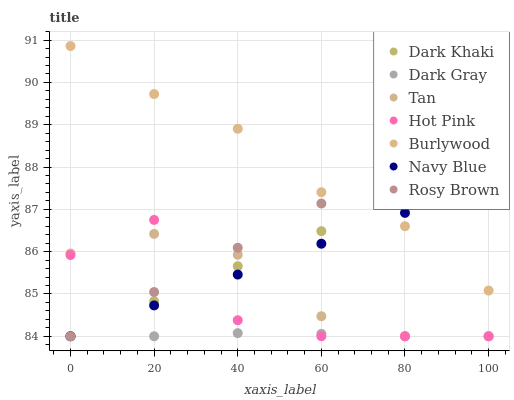Does Dark Gray have the minimum area under the curve?
Answer yes or no. Yes. Does Burlywood have the maximum area under the curve?
Answer yes or no. Yes. Does Rosy Brown have the minimum area under the curve?
Answer yes or no. No. Does Rosy Brown have the maximum area under the curve?
Answer yes or no. No. Is Dark Khaki the smoothest?
Answer yes or no. Yes. Is Hot Pink the roughest?
Answer yes or no. Yes. Is Rosy Brown the smoothest?
Answer yes or no. No. Is Rosy Brown the roughest?
Answer yes or no. No. Does Dark Gray have the lowest value?
Answer yes or no. Yes. Does Burlywood have the lowest value?
Answer yes or no. No. Does Burlywood have the highest value?
Answer yes or no. Yes. Does Rosy Brown have the highest value?
Answer yes or no. No. Is Hot Pink less than Burlywood?
Answer yes or no. Yes. Is Burlywood greater than Dark Gray?
Answer yes or no. Yes. Does Tan intersect Rosy Brown?
Answer yes or no. Yes. Is Tan less than Rosy Brown?
Answer yes or no. No. Is Tan greater than Rosy Brown?
Answer yes or no. No. Does Hot Pink intersect Burlywood?
Answer yes or no. No. 